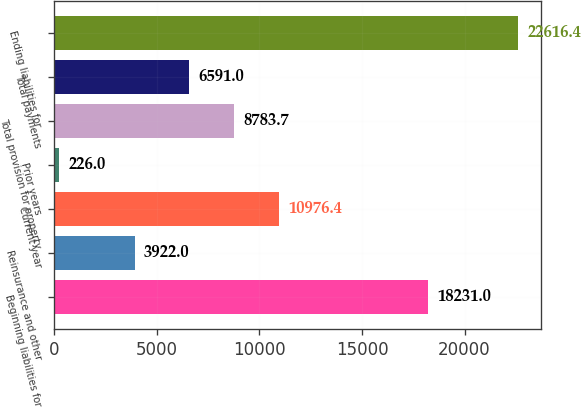Convert chart to OTSL. <chart><loc_0><loc_0><loc_500><loc_500><bar_chart><fcel>Beginning liabilities for<fcel>Reinsurance and other<fcel>Current year<fcel>Prior years<fcel>Total provision for property<fcel>Total payments<fcel>Ending liabilities for<nl><fcel>18231<fcel>3922<fcel>10976.4<fcel>226<fcel>8783.7<fcel>6591<fcel>22616.4<nl></chart> 